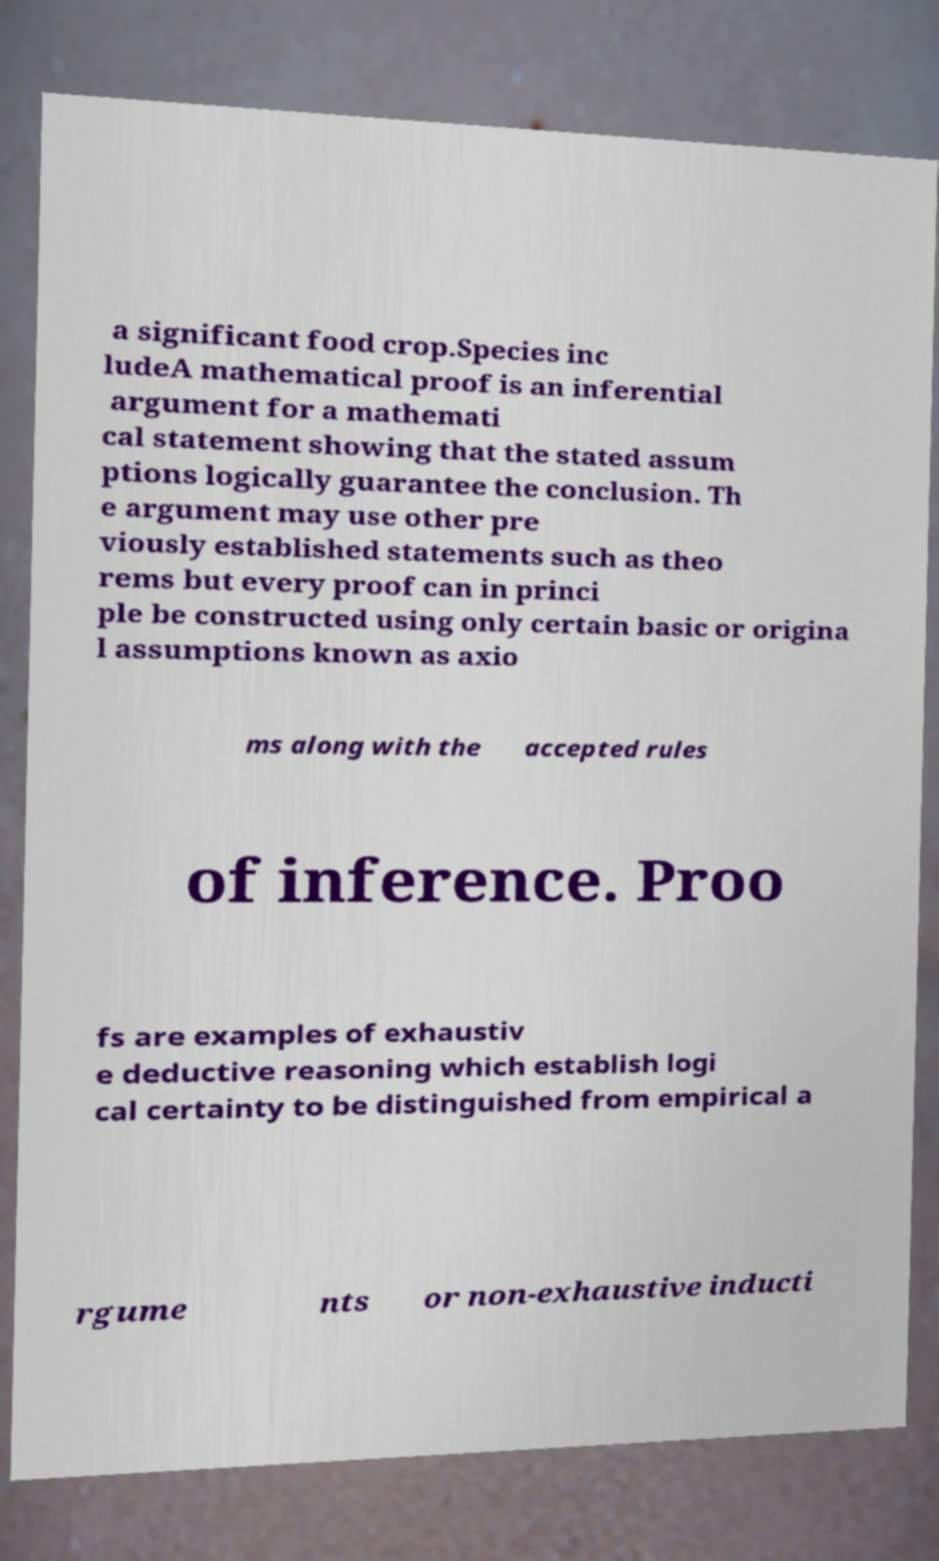There's text embedded in this image that I need extracted. Can you transcribe it verbatim? a significant food crop.Species inc ludeA mathematical proof is an inferential argument for a mathemati cal statement showing that the stated assum ptions logically guarantee the conclusion. Th e argument may use other pre viously established statements such as theo rems but every proof can in princi ple be constructed using only certain basic or origina l assumptions known as axio ms along with the accepted rules of inference. Proo fs are examples of exhaustiv e deductive reasoning which establish logi cal certainty to be distinguished from empirical a rgume nts or non-exhaustive inducti 